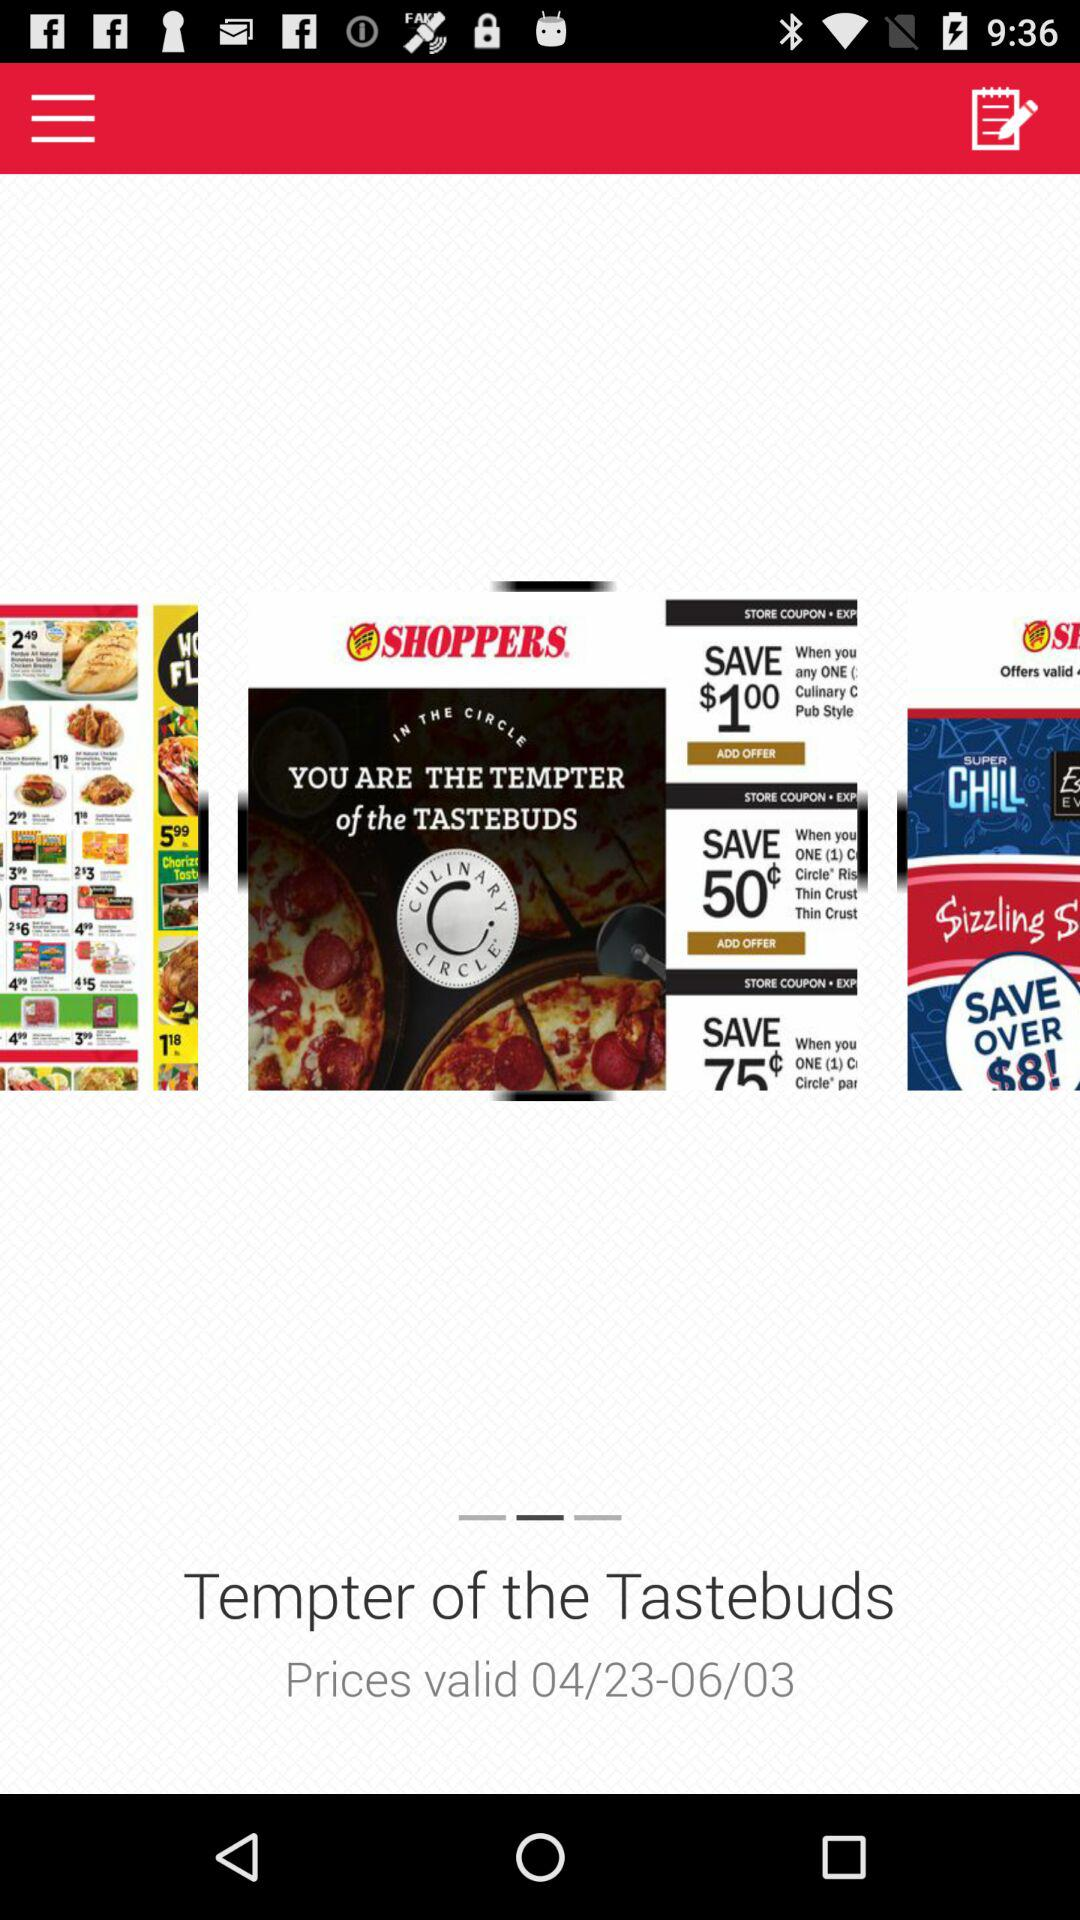Until which date is the price valid? The price is valid until June 3. 